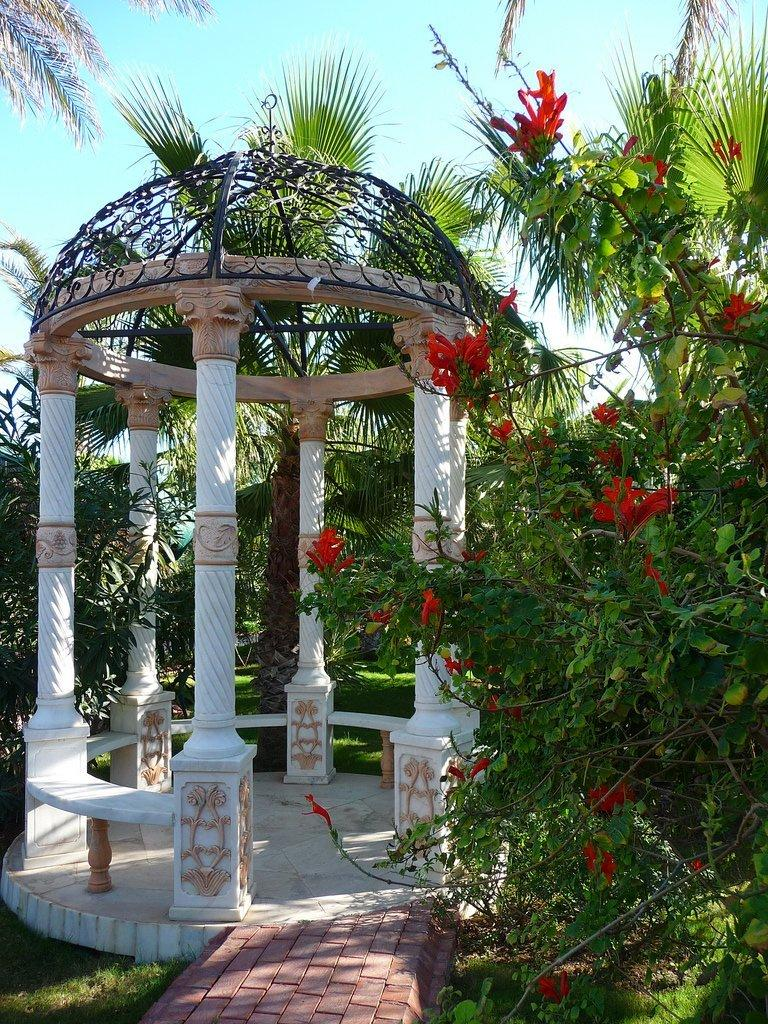What type of structure can be seen in the picture? There is a gazebo in the picture. What type of plants are present in the picture? There are flowers and trees in the picture. What can be seen in the background of the picture? The sky is visible in the background of the picture. Where is the faucet located in the picture? There is no faucet present in the picture. What type of amusement can be seen in the picture? There is no amusement depicted in the picture; it features a gazebo, flowers, trees, and the sky. 